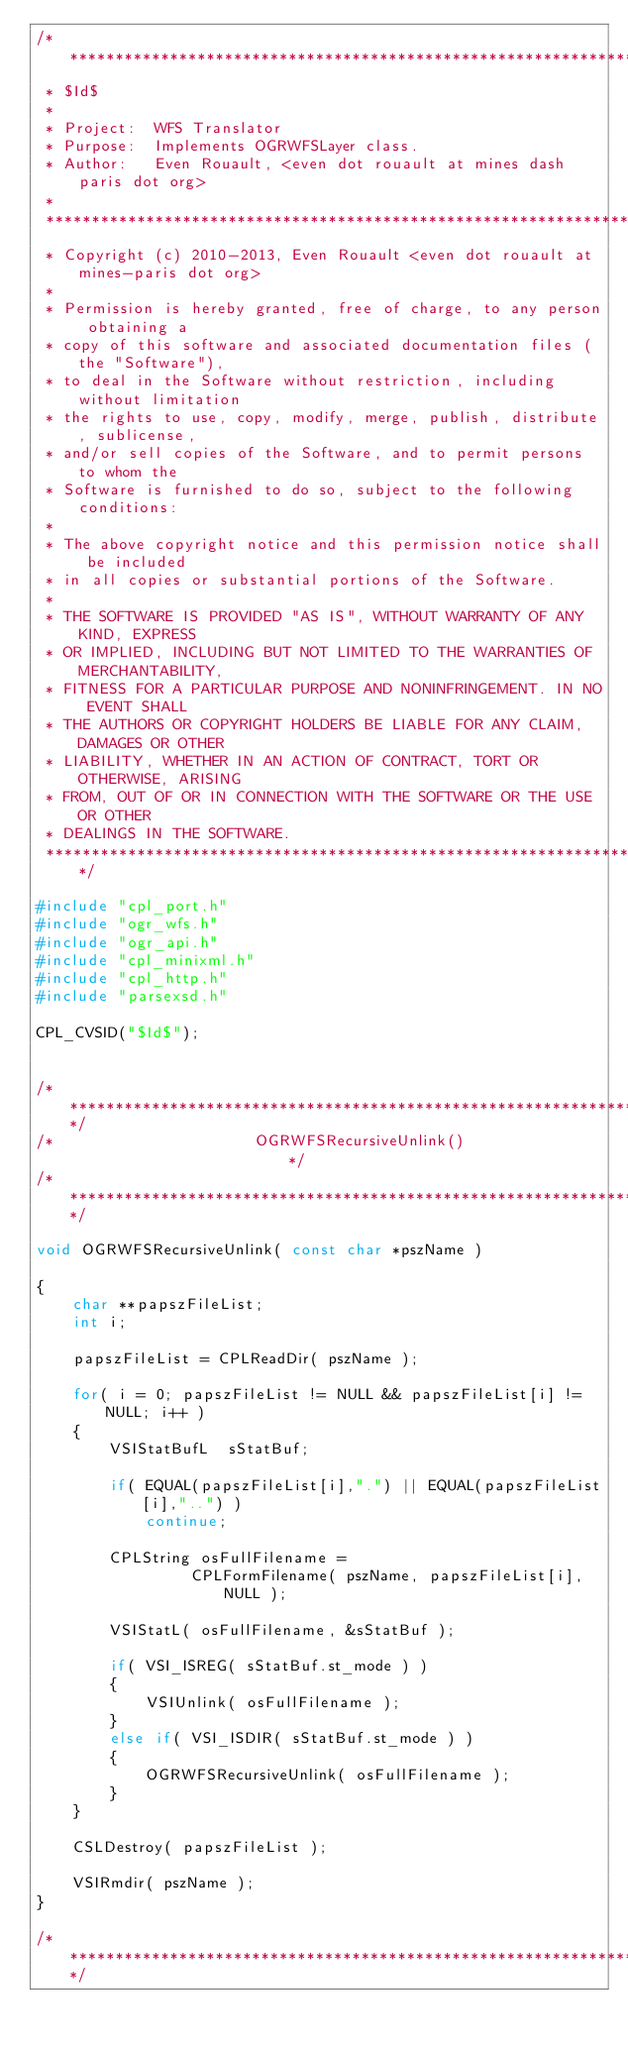<code> <loc_0><loc_0><loc_500><loc_500><_C++_>/******************************************************************************
 * $Id$
 *
 * Project:  WFS Translator
 * Purpose:  Implements OGRWFSLayer class.
 * Author:   Even Rouault, <even dot rouault at mines dash paris dot org>
 *
 ******************************************************************************
 * Copyright (c) 2010-2013, Even Rouault <even dot rouault at mines-paris dot org>
 *
 * Permission is hereby granted, free of charge, to any person obtaining a
 * copy of this software and associated documentation files (the "Software"),
 * to deal in the Software without restriction, including without limitation
 * the rights to use, copy, modify, merge, publish, distribute, sublicense,
 * and/or sell copies of the Software, and to permit persons to whom the
 * Software is furnished to do so, subject to the following conditions:
 *
 * The above copyright notice and this permission notice shall be included
 * in all copies or substantial portions of the Software.
 *
 * THE SOFTWARE IS PROVIDED "AS IS", WITHOUT WARRANTY OF ANY KIND, EXPRESS
 * OR IMPLIED, INCLUDING BUT NOT LIMITED TO THE WARRANTIES OF MERCHANTABILITY,
 * FITNESS FOR A PARTICULAR PURPOSE AND NONINFRINGEMENT. IN NO EVENT SHALL
 * THE AUTHORS OR COPYRIGHT HOLDERS BE LIABLE FOR ANY CLAIM, DAMAGES OR OTHER
 * LIABILITY, WHETHER IN AN ACTION OF CONTRACT, TORT OR OTHERWISE, ARISING
 * FROM, OUT OF OR IN CONNECTION WITH THE SOFTWARE OR THE USE OR OTHER
 * DEALINGS IN THE SOFTWARE.
 ****************************************************************************/

#include "cpl_port.h"
#include "ogr_wfs.h"
#include "ogr_api.h"
#include "cpl_minixml.h"
#include "cpl_http.h"
#include "parsexsd.h"

CPL_CVSID("$Id$");


/************************************************************************/
/*                      OGRWFSRecursiveUnlink()                         */
/************************************************************************/

void OGRWFSRecursiveUnlink( const char *pszName )

{
    char **papszFileList;
    int i;

    papszFileList = CPLReadDir( pszName );

    for( i = 0; papszFileList != NULL && papszFileList[i] != NULL; i++ )
    {
        VSIStatBufL  sStatBuf;

        if( EQUAL(papszFileList[i],".") || EQUAL(papszFileList[i],"..") )
            continue;

        CPLString osFullFilename =
                 CPLFormFilename( pszName, papszFileList[i], NULL );

        VSIStatL( osFullFilename, &sStatBuf );

        if( VSI_ISREG( sStatBuf.st_mode ) )
        {
            VSIUnlink( osFullFilename );
        }
        else if( VSI_ISDIR( sStatBuf.st_mode ) )
        {
            OGRWFSRecursiveUnlink( osFullFilename );
        }
    }

    CSLDestroy( papszFileList );

    VSIRmdir( pszName );
}

/************************************************************************/</code> 